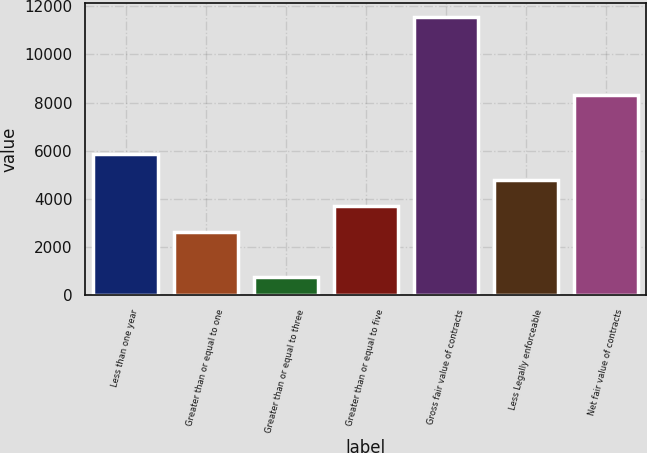<chart> <loc_0><loc_0><loc_500><loc_500><bar_chart><fcel>Less than one year<fcel>Greater than or equal to one<fcel>Greater than or equal to three<fcel>Greater than or equal to five<fcel>Gross fair value of contracts<fcel>Less Legally enforceable<fcel>Net fair value of contracts<nl><fcel>5865<fcel>2619<fcel>723<fcel>3701<fcel>11543<fcel>4783<fcel>8299<nl></chart> 